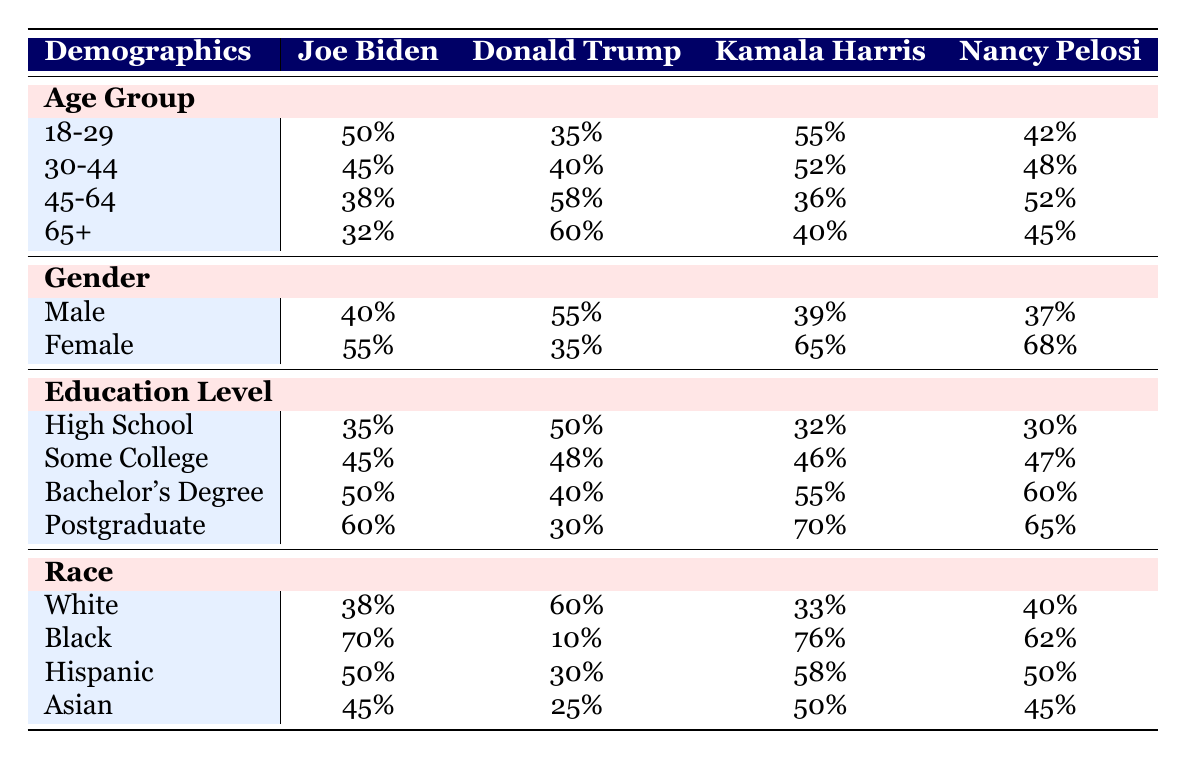What is Joe Biden's approval rating among females? The table indicates Joe Biden's approval rating among females is listed under the gender category, where it shows a value of 55%.
Answer: 55% Which political leader has the highest approval rating among the 18-29 age group? Comparing the ratings in the 18-29 age group, Joe Biden has 50%, Donald Trump has 35%, Kamala Harris has 55%, and Nancy Pelosi has 42%. The highest value is 55% for Kamala Harris.
Answer: Kamala Harris What is the difference in approval ratings between Kamala Harris and Donald Trump among the 45-64 age group? Under the 45-64 age group, Kamala Harris has 36% and Donald Trump has 58%. To find the difference, calculate 58% - 36% = 22%.
Answer: 22% Is it true that more males approve of Donald Trump than Joe Biden? Checking the male approval ratings, Donald Trump has 55% approval while Joe Biden has 40%. Since 55% is greater than 40%, the statement is true.
Answer: Yes What is the average approval rating for the "Postgraduate" education level across all leaders? For postgraduate education, the ratings are Joe Biden: 60%, Donald Trump: 30%, Kamala Harris: 70%, and Nancy Pelosi: 65%. Summing these gives 60 + 30 + 70 + 65 = 225. Dividing by 4 gives an average of 225 / 4 = 56.25%.
Answer: 56.25% Which racial group has the highest approval rating for Joe Biden? Looking at the race category, the approval ratings for Joe Biden by race are: White 38%, Black 70%, Hispanic 50%, Asian 45%. The highest rating is 70% among the Black demographic.
Answer: Black Among the "Some College" demographic, which leader has the lowest approval rating? Checking the "Some College" ratings, Joe Biden has 45%, Donald Trump has 48%, Kamala Harris has 46%, and Nancy Pelosi has 47%. The lowest rating is 45% for Joe Biden.
Answer: Joe Biden What percentage of White voters approve of Donald Trump? The table shows that Donald Trump's approval rating among White voters is 60%.
Answer: 60% Who has the highest overall approval rating for the Hispanic demographic? For Hispanics, Joe Biden has 50%, Donald Trump has 30%, Kamala Harris has 58%, and Nancy Pelosi has 50%. The maximum approval is 58% for Kamala Harris.
Answer: Kamala Harris 